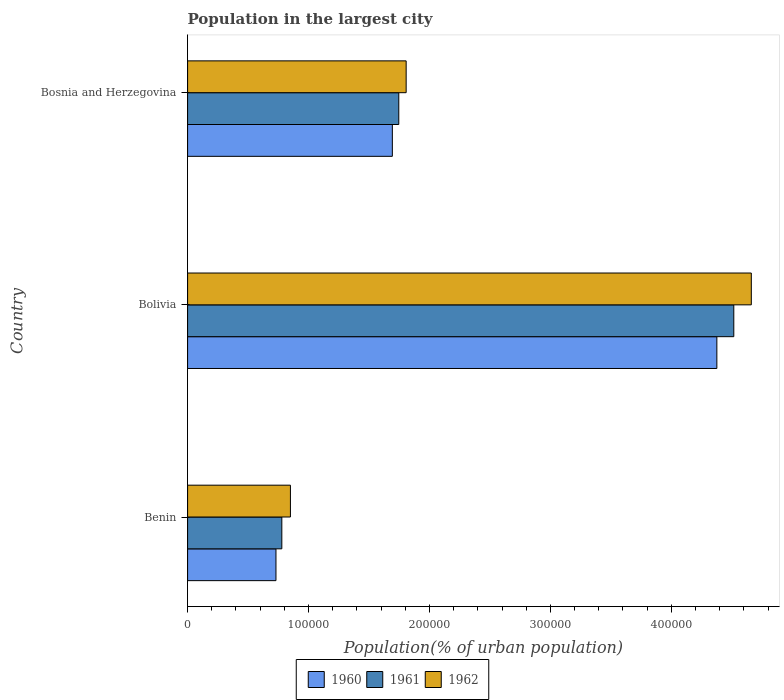How many different coloured bars are there?
Your response must be concise. 3. How many groups of bars are there?
Provide a short and direct response. 3. Are the number of bars per tick equal to the number of legend labels?
Keep it short and to the point. Yes. Are the number of bars on each tick of the Y-axis equal?
Your answer should be very brief. Yes. How many bars are there on the 1st tick from the top?
Offer a very short reply. 3. In how many cases, is the number of bars for a given country not equal to the number of legend labels?
Your response must be concise. 0. What is the population in the largest city in 1960 in Bolivia?
Provide a succinct answer. 4.38e+05. Across all countries, what is the maximum population in the largest city in 1961?
Keep it short and to the point. 4.52e+05. Across all countries, what is the minimum population in the largest city in 1960?
Provide a succinct answer. 7.31e+04. In which country was the population in the largest city in 1962 maximum?
Provide a succinct answer. Bolivia. In which country was the population in the largest city in 1961 minimum?
Your answer should be compact. Benin. What is the total population in the largest city in 1962 in the graph?
Offer a very short reply. 7.32e+05. What is the difference between the population in the largest city in 1962 in Benin and that in Bolivia?
Provide a short and direct response. -3.81e+05. What is the difference between the population in the largest city in 1961 in Bolivia and the population in the largest city in 1962 in Bosnia and Herzegovina?
Offer a very short reply. 2.71e+05. What is the average population in the largest city in 1962 per country?
Your response must be concise. 2.44e+05. What is the difference between the population in the largest city in 1962 and population in the largest city in 1960 in Bolivia?
Offer a very short reply. 2.85e+04. What is the ratio of the population in the largest city in 1960 in Bolivia to that in Bosnia and Herzegovina?
Your answer should be compact. 2.58. Is the difference between the population in the largest city in 1962 in Bolivia and Bosnia and Herzegovina greater than the difference between the population in the largest city in 1960 in Bolivia and Bosnia and Herzegovina?
Your answer should be compact. Yes. What is the difference between the highest and the second highest population in the largest city in 1962?
Ensure brevity in your answer.  2.85e+05. What is the difference between the highest and the lowest population in the largest city in 1962?
Offer a terse response. 3.81e+05. In how many countries, is the population in the largest city in 1960 greater than the average population in the largest city in 1960 taken over all countries?
Your answer should be very brief. 1. What does the 1st bar from the top in Benin represents?
Make the answer very short. 1962. How many bars are there?
Ensure brevity in your answer.  9. How many countries are there in the graph?
Give a very brief answer. 3. Are the values on the major ticks of X-axis written in scientific E-notation?
Keep it short and to the point. No. Does the graph contain any zero values?
Make the answer very short. No. How many legend labels are there?
Offer a very short reply. 3. How are the legend labels stacked?
Provide a short and direct response. Horizontal. What is the title of the graph?
Your response must be concise. Population in the largest city. What is the label or title of the X-axis?
Your answer should be compact. Population(% of urban population). What is the label or title of the Y-axis?
Provide a succinct answer. Country. What is the Population(% of urban population) in 1960 in Benin?
Offer a very short reply. 7.31e+04. What is the Population(% of urban population) of 1961 in Benin?
Provide a short and direct response. 7.79e+04. What is the Population(% of urban population) in 1962 in Benin?
Keep it short and to the point. 8.50e+04. What is the Population(% of urban population) in 1960 in Bolivia?
Make the answer very short. 4.38e+05. What is the Population(% of urban population) in 1961 in Bolivia?
Offer a terse response. 4.52e+05. What is the Population(% of urban population) of 1962 in Bolivia?
Make the answer very short. 4.66e+05. What is the Population(% of urban population) of 1960 in Bosnia and Herzegovina?
Give a very brief answer. 1.69e+05. What is the Population(% of urban population) of 1961 in Bosnia and Herzegovina?
Ensure brevity in your answer.  1.75e+05. What is the Population(% of urban population) in 1962 in Bosnia and Herzegovina?
Your answer should be compact. 1.81e+05. Across all countries, what is the maximum Population(% of urban population) in 1960?
Your response must be concise. 4.38e+05. Across all countries, what is the maximum Population(% of urban population) in 1961?
Offer a very short reply. 4.52e+05. Across all countries, what is the maximum Population(% of urban population) of 1962?
Provide a succinct answer. 4.66e+05. Across all countries, what is the minimum Population(% of urban population) of 1960?
Your answer should be very brief. 7.31e+04. Across all countries, what is the minimum Population(% of urban population) of 1961?
Offer a very short reply. 7.79e+04. Across all countries, what is the minimum Population(% of urban population) in 1962?
Your answer should be very brief. 8.50e+04. What is the total Population(% of urban population) of 1960 in the graph?
Keep it short and to the point. 6.80e+05. What is the total Population(% of urban population) of 1961 in the graph?
Your response must be concise. 7.04e+05. What is the total Population(% of urban population) in 1962 in the graph?
Offer a terse response. 7.32e+05. What is the difference between the Population(% of urban population) in 1960 in Benin and that in Bolivia?
Offer a terse response. -3.65e+05. What is the difference between the Population(% of urban population) in 1961 in Benin and that in Bolivia?
Offer a terse response. -3.74e+05. What is the difference between the Population(% of urban population) of 1962 in Benin and that in Bolivia?
Ensure brevity in your answer.  -3.81e+05. What is the difference between the Population(% of urban population) in 1960 in Benin and that in Bosnia and Herzegovina?
Offer a terse response. -9.62e+04. What is the difference between the Population(% of urban population) in 1961 in Benin and that in Bosnia and Herzegovina?
Offer a very short reply. -9.67e+04. What is the difference between the Population(% of urban population) of 1962 in Benin and that in Bosnia and Herzegovina?
Offer a very short reply. -9.57e+04. What is the difference between the Population(% of urban population) in 1960 in Bolivia and that in Bosnia and Herzegovina?
Keep it short and to the point. 2.68e+05. What is the difference between the Population(% of urban population) of 1961 in Bolivia and that in Bosnia and Herzegovina?
Offer a terse response. 2.77e+05. What is the difference between the Population(% of urban population) in 1962 in Bolivia and that in Bosnia and Herzegovina?
Ensure brevity in your answer.  2.85e+05. What is the difference between the Population(% of urban population) in 1960 in Benin and the Population(% of urban population) in 1961 in Bolivia?
Your answer should be very brief. -3.79e+05. What is the difference between the Population(% of urban population) in 1960 in Benin and the Population(% of urban population) in 1962 in Bolivia?
Make the answer very short. -3.93e+05. What is the difference between the Population(% of urban population) of 1961 in Benin and the Population(% of urban population) of 1962 in Bolivia?
Keep it short and to the point. -3.88e+05. What is the difference between the Population(% of urban population) in 1960 in Benin and the Population(% of urban population) in 1961 in Bosnia and Herzegovina?
Make the answer very short. -1.02e+05. What is the difference between the Population(% of urban population) in 1960 in Benin and the Population(% of urban population) in 1962 in Bosnia and Herzegovina?
Make the answer very short. -1.08e+05. What is the difference between the Population(% of urban population) of 1961 in Benin and the Population(% of urban population) of 1962 in Bosnia and Herzegovina?
Make the answer very short. -1.03e+05. What is the difference between the Population(% of urban population) in 1960 in Bolivia and the Population(% of urban population) in 1961 in Bosnia and Herzegovina?
Keep it short and to the point. 2.63e+05. What is the difference between the Population(% of urban population) of 1960 in Bolivia and the Population(% of urban population) of 1962 in Bosnia and Herzegovina?
Offer a very short reply. 2.57e+05. What is the difference between the Population(% of urban population) of 1961 in Bolivia and the Population(% of urban population) of 1962 in Bosnia and Herzegovina?
Provide a succinct answer. 2.71e+05. What is the average Population(% of urban population) in 1960 per country?
Provide a short and direct response. 2.27e+05. What is the average Population(% of urban population) of 1961 per country?
Provide a short and direct response. 2.35e+05. What is the average Population(% of urban population) of 1962 per country?
Provide a succinct answer. 2.44e+05. What is the difference between the Population(% of urban population) of 1960 and Population(% of urban population) of 1961 in Benin?
Your answer should be very brief. -4848. What is the difference between the Population(% of urban population) of 1960 and Population(% of urban population) of 1962 in Benin?
Your response must be concise. -1.20e+04. What is the difference between the Population(% of urban population) of 1961 and Population(% of urban population) of 1962 in Benin?
Provide a succinct answer. -7108. What is the difference between the Population(% of urban population) in 1960 and Population(% of urban population) in 1961 in Bolivia?
Keep it short and to the point. -1.40e+04. What is the difference between the Population(% of urban population) of 1960 and Population(% of urban population) of 1962 in Bolivia?
Keep it short and to the point. -2.85e+04. What is the difference between the Population(% of urban population) in 1961 and Population(% of urban population) in 1962 in Bolivia?
Your answer should be compact. -1.45e+04. What is the difference between the Population(% of urban population) of 1960 and Population(% of urban population) of 1961 in Bosnia and Herzegovina?
Provide a short and direct response. -5328. What is the difference between the Population(% of urban population) of 1960 and Population(% of urban population) of 1962 in Bosnia and Herzegovina?
Your answer should be compact. -1.14e+04. What is the difference between the Population(% of urban population) of 1961 and Population(% of urban population) of 1962 in Bosnia and Herzegovina?
Your answer should be compact. -6094. What is the ratio of the Population(% of urban population) in 1960 in Benin to that in Bolivia?
Ensure brevity in your answer.  0.17. What is the ratio of the Population(% of urban population) in 1961 in Benin to that in Bolivia?
Offer a terse response. 0.17. What is the ratio of the Population(% of urban population) in 1962 in Benin to that in Bolivia?
Offer a terse response. 0.18. What is the ratio of the Population(% of urban population) of 1960 in Benin to that in Bosnia and Herzegovina?
Your response must be concise. 0.43. What is the ratio of the Population(% of urban population) in 1961 in Benin to that in Bosnia and Herzegovina?
Offer a very short reply. 0.45. What is the ratio of the Population(% of urban population) of 1962 in Benin to that in Bosnia and Herzegovina?
Your response must be concise. 0.47. What is the ratio of the Population(% of urban population) in 1960 in Bolivia to that in Bosnia and Herzegovina?
Make the answer very short. 2.58. What is the ratio of the Population(% of urban population) of 1961 in Bolivia to that in Bosnia and Herzegovina?
Give a very brief answer. 2.59. What is the ratio of the Population(% of urban population) in 1962 in Bolivia to that in Bosnia and Herzegovina?
Your answer should be compact. 2.58. What is the difference between the highest and the second highest Population(% of urban population) in 1960?
Make the answer very short. 2.68e+05. What is the difference between the highest and the second highest Population(% of urban population) of 1961?
Provide a succinct answer. 2.77e+05. What is the difference between the highest and the second highest Population(% of urban population) in 1962?
Provide a short and direct response. 2.85e+05. What is the difference between the highest and the lowest Population(% of urban population) of 1960?
Offer a very short reply. 3.65e+05. What is the difference between the highest and the lowest Population(% of urban population) in 1961?
Provide a short and direct response. 3.74e+05. What is the difference between the highest and the lowest Population(% of urban population) of 1962?
Provide a short and direct response. 3.81e+05. 